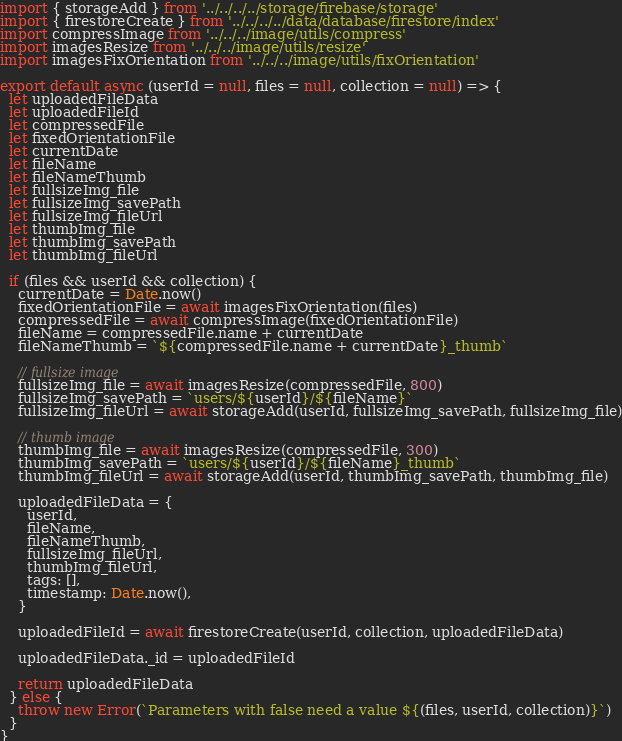Convert code to text. <code><loc_0><loc_0><loc_500><loc_500><_JavaScript_>import { storageAdd } from '../../../../storage/firebase/storage'
import { firestoreCreate } from '../../../../data/database/firestore/index'
import compressImage from '../../../image/utils/compress'
import imagesResize from '../../../image/utils/resize'
import imagesFixOrientation from '../../../image/utils/fixOrientation'

export default async (userId = null, files = null, collection = null) => {
  let uploadedFileData
  let uploadedFileId
  let compressedFile
  let fixedOrientationFile
  let currentDate
  let fileName
  let fileNameThumb
  let fullsizeImg_file
  let fullsizeImg_savePath
  let fullsizeImg_fileUrl
  let thumbImg_file
  let thumbImg_savePath
  let thumbImg_fileUrl

  if (files && userId && collection) {
    currentDate = Date.now()
    fixedOrientationFile = await imagesFixOrientation(files)
    compressedFile = await compressImage(fixedOrientationFile)
    fileName = compressedFile.name + currentDate
    fileNameThumb = `${compressedFile.name + currentDate}_thumb`

    // fullsize image
    fullsizeImg_file = await imagesResize(compressedFile, 800)
    fullsizeImg_savePath = `users/${userId}/${fileName}`
    fullsizeImg_fileUrl = await storageAdd(userId, fullsizeImg_savePath, fullsizeImg_file)

    // thumb image
    thumbImg_file = await imagesResize(compressedFile, 300)
    thumbImg_savePath = `users/${userId}/${fileName}_thumb`
    thumbImg_fileUrl = await storageAdd(userId, thumbImg_savePath, thumbImg_file)

    uploadedFileData = {
      userId,
      fileName,
      fileNameThumb,
      fullsizeImg_fileUrl,
      thumbImg_fileUrl,
      tags: [],
      timestamp: Date.now(),
    }

    uploadedFileId = await firestoreCreate(userId, collection, uploadedFileData)

    uploadedFileData._id = uploadedFileId

    return uploadedFileData
  } else {
    throw new Error(`Parameters with false need a value ${(files, userId, collection)}`)
  }
}
</code> 